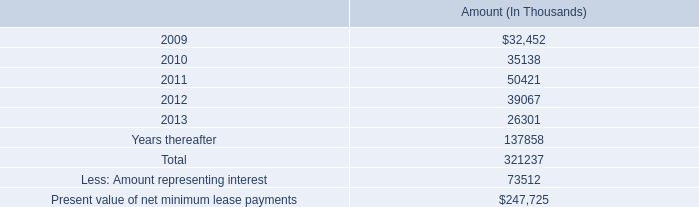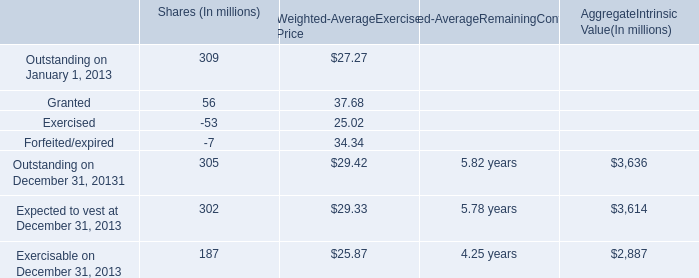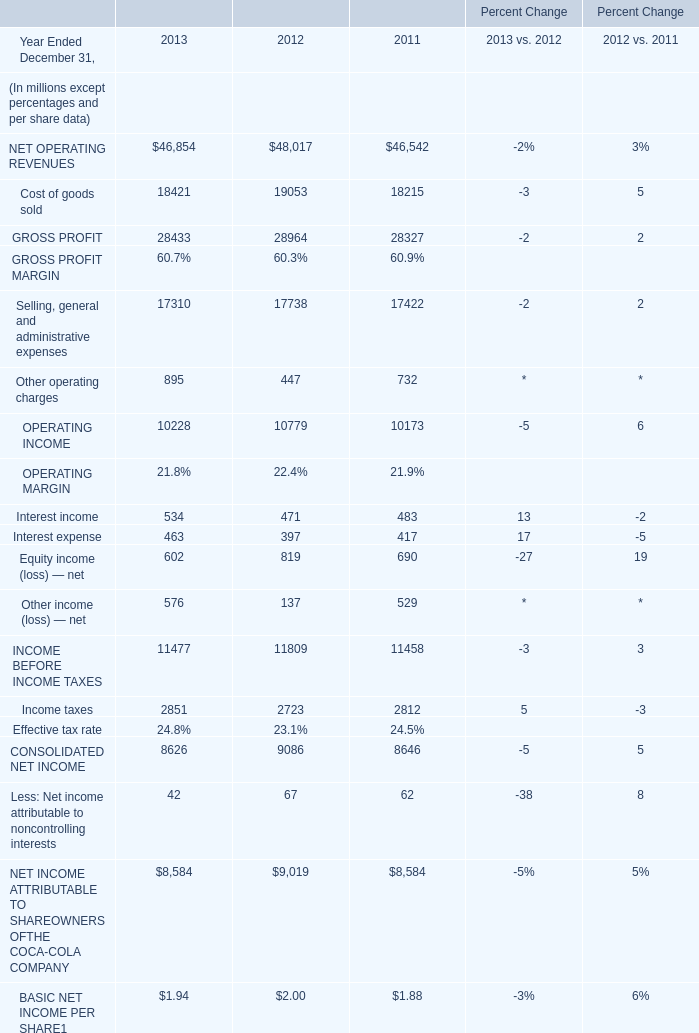In the year with highest CONSOLIDATED NET INCOME, what's the growing rate of Interest income? 
Computations: ((471 - 483) / 483)
Answer: -0.02484. 